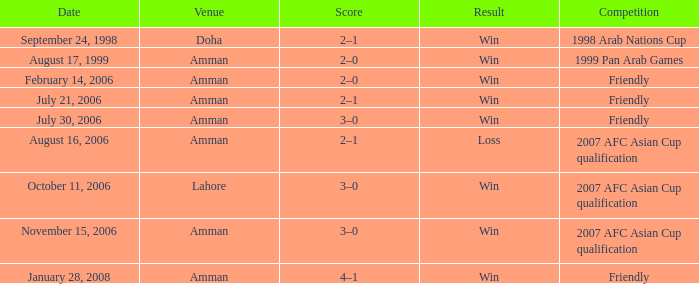Where did Ra'fat Ali play on August 17, 1999? Amman. 